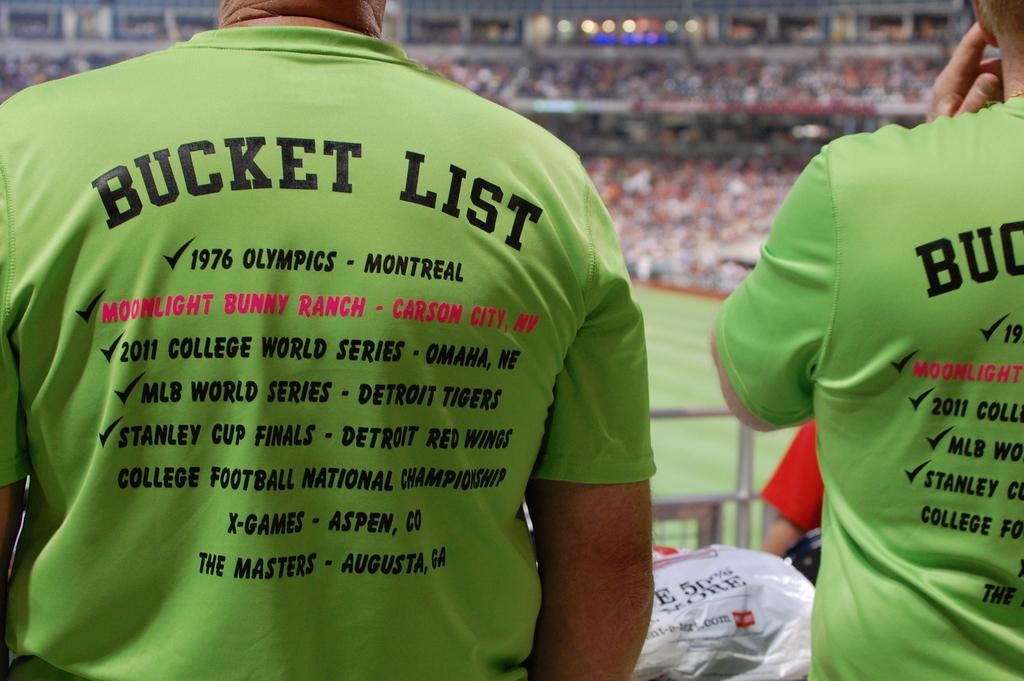<image>
Provide a brief description of the given image. Two people are sitting in the stands of a sports game wearing matching, green shirts that say Bucket List on the back. 